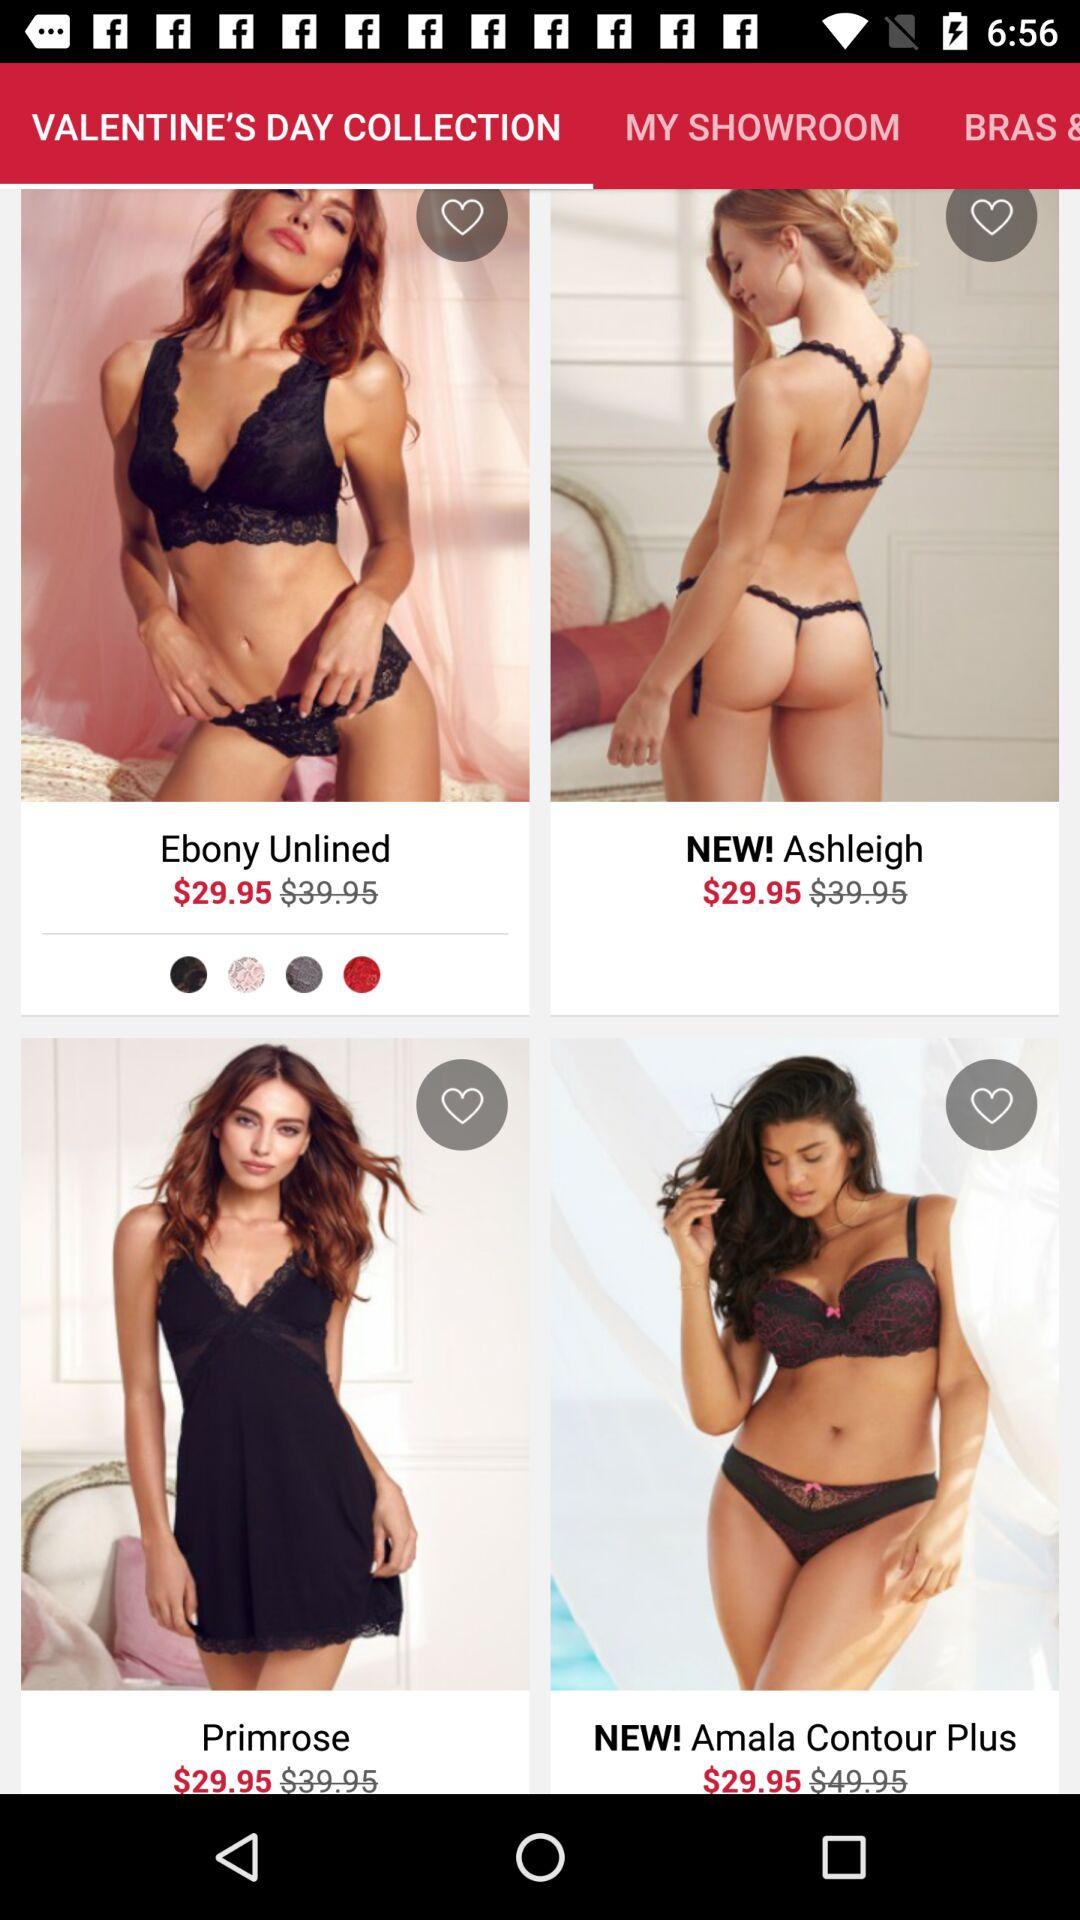What is the price of the primrose? The price of the primrose is $29.95. 